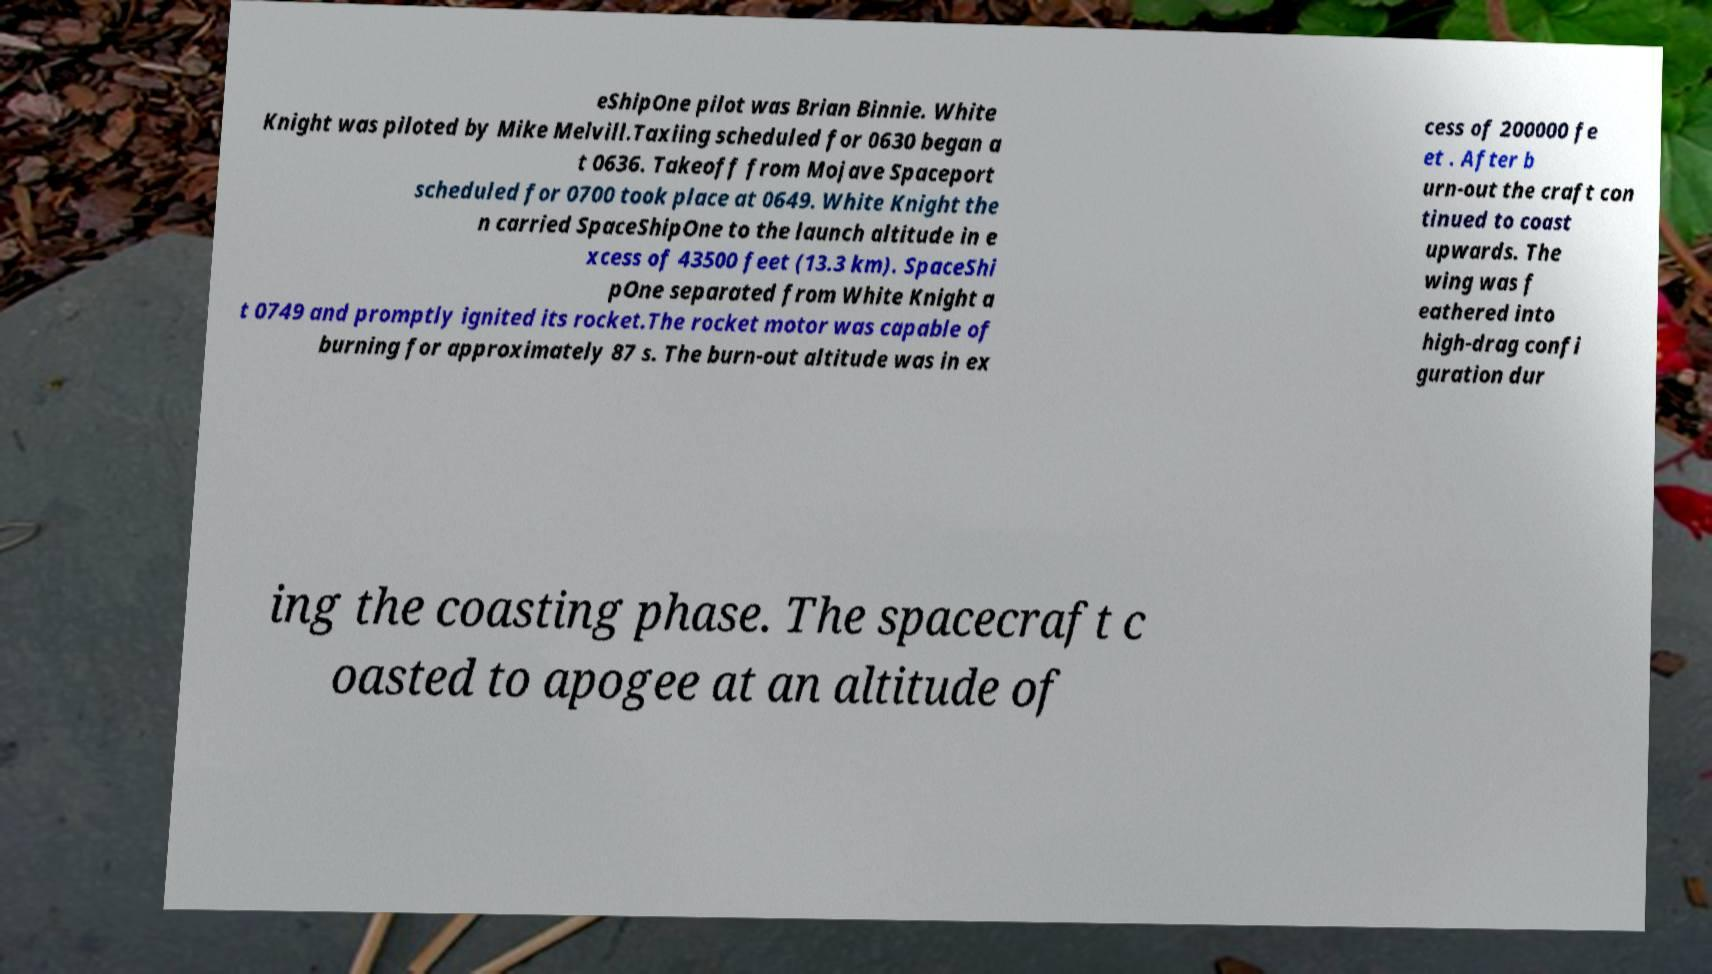For documentation purposes, I need the text within this image transcribed. Could you provide that? eShipOne pilot was Brian Binnie. White Knight was piloted by Mike Melvill.Taxiing scheduled for 0630 began a t 0636. Takeoff from Mojave Spaceport scheduled for 0700 took place at 0649. White Knight the n carried SpaceShipOne to the launch altitude in e xcess of 43500 feet (13.3 km). SpaceShi pOne separated from White Knight a t 0749 and promptly ignited its rocket.The rocket motor was capable of burning for approximately 87 s. The burn-out altitude was in ex cess of 200000 fe et . After b urn-out the craft con tinued to coast upwards. The wing was f eathered into high-drag confi guration dur ing the coasting phase. The spacecraft c oasted to apogee at an altitude of 